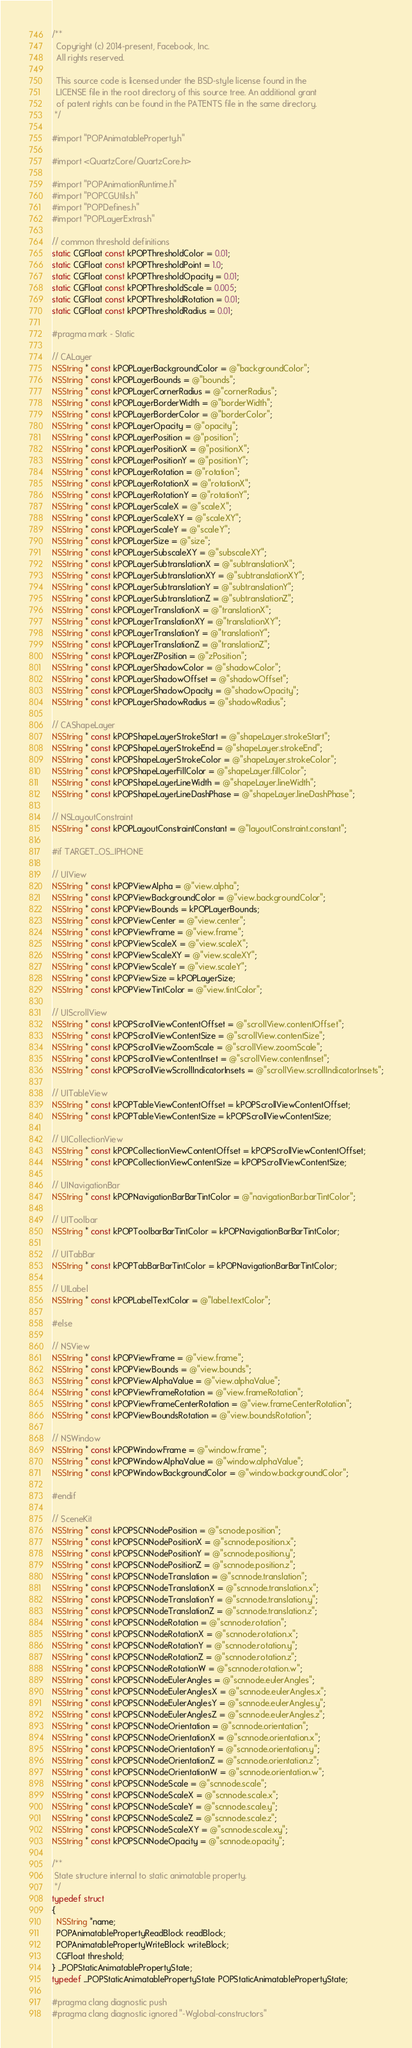<code> <loc_0><loc_0><loc_500><loc_500><_ObjectiveC_>/**
  Copyright (c) 2014-present, Facebook, Inc.
  All rights reserved.

  This source code is licensed under the BSD-style license found in the
  LICENSE file in the root directory of this source tree. An additional grant
  of patent rights can be found in the PATENTS file in the same directory.
 */

#import "POPAnimatableProperty.h"

#import <QuartzCore/QuartzCore.h>

#import "POPAnimationRuntime.h"
#import "POPCGUtils.h"
#import "POPDefines.h"
#import "POPLayerExtras.h"

// common threshold definitions
static CGFloat const kPOPThresholdColor = 0.01;
static CGFloat const kPOPThresholdPoint = 1.0;
static CGFloat const kPOPThresholdOpacity = 0.01;
static CGFloat const kPOPThresholdScale = 0.005;
static CGFloat const kPOPThresholdRotation = 0.01;
static CGFloat const kPOPThresholdRadius = 0.01;

#pragma mark - Static

// CALayer
NSString * const kPOPLayerBackgroundColor = @"backgroundColor";
NSString * const kPOPLayerBounds = @"bounds";
NSString * const kPOPLayerCornerRadius = @"cornerRadius";
NSString * const kPOPLayerBorderWidth = @"borderWidth";
NSString * const kPOPLayerBorderColor = @"borderColor";
NSString * const kPOPLayerOpacity = @"opacity";
NSString * const kPOPLayerPosition = @"position";
NSString * const kPOPLayerPositionX = @"positionX";
NSString * const kPOPLayerPositionY = @"positionY";
NSString * const kPOPLayerRotation = @"rotation";
NSString * const kPOPLayerRotationX = @"rotationX";
NSString * const kPOPLayerRotationY = @"rotationY";
NSString * const kPOPLayerScaleX = @"scaleX";
NSString * const kPOPLayerScaleXY = @"scaleXY";
NSString * const kPOPLayerScaleY = @"scaleY";
NSString * const kPOPLayerSize = @"size";
NSString * const kPOPLayerSubscaleXY = @"subscaleXY";
NSString * const kPOPLayerSubtranslationX = @"subtranslationX";
NSString * const kPOPLayerSubtranslationXY = @"subtranslationXY";
NSString * const kPOPLayerSubtranslationY = @"subtranslationY";
NSString * const kPOPLayerSubtranslationZ = @"subtranslationZ";
NSString * const kPOPLayerTranslationX = @"translationX";
NSString * const kPOPLayerTranslationXY = @"translationXY";
NSString * const kPOPLayerTranslationY = @"translationY";
NSString * const kPOPLayerTranslationZ = @"translationZ";
NSString * const kPOPLayerZPosition = @"zPosition";
NSString * const kPOPLayerShadowColor = @"shadowColor";
NSString * const kPOPLayerShadowOffset = @"shadowOffset";
NSString * const kPOPLayerShadowOpacity = @"shadowOpacity";
NSString * const kPOPLayerShadowRadius = @"shadowRadius";

// CAShapeLayer
NSString * const kPOPShapeLayerStrokeStart = @"shapeLayer.strokeStart";
NSString * const kPOPShapeLayerStrokeEnd = @"shapeLayer.strokeEnd";
NSString * const kPOPShapeLayerStrokeColor = @"shapeLayer.strokeColor";
NSString * const kPOPShapeLayerFillColor = @"shapeLayer.fillColor";
NSString * const kPOPShapeLayerLineWidth = @"shapeLayer.lineWidth";
NSString * const kPOPShapeLayerLineDashPhase = @"shapeLayer.lineDashPhase";

// NSLayoutConstraint
NSString * const kPOPLayoutConstraintConstant = @"layoutConstraint.constant";

#if TARGET_OS_IPHONE

// UIView
NSString * const kPOPViewAlpha = @"view.alpha";
NSString * const kPOPViewBackgroundColor = @"view.backgroundColor";
NSString * const kPOPViewBounds = kPOPLayerBounds;
NSString * const kPOPViewCenter = @"view.center";
NSString * const kPOPViewFrame = @"view.frame";
NSString * const kPOPViewScaleX = @"view.scaleX";
NSString * const kPOPViewScaleXY = @"view.scaleXY";
NSString * const kPOPViewScaleY = @"view.scaleY";
NSString * const kPOPViewSize = kPOPLayerSize;
NSString * const kPOPViewTintColor = @"view.tintColor";

// UIScrollView
NSString * const kPOPScrollViewContentOffset = @"scrollView.contentOffset";
NSString * const kPOPScrollViewContentSize = @"scrollView.contentSize";
NSString * const kPOPScrollViewZoomScale = @"scrollView.zoomScale";
NSString * const kPOPScrollViewContentInset = @"scrollView.contentInset";
NSString * const kPOPScrollViewScrollIndicatorInsets = @"scrollView.scrollIndicatorInsets";

// UITableView
NSString * const kPOPTableViewContentOffset = kPOPScrollViewContentOffset;
NSString * const kPOPTableViewContentSize = kPOPScrollViewContentSize;

// UICollectionView
NSString * const kPOPCollectionViewContentOffset = kPOPScrollViewContentOffset;
NSString * const kPOPCollectionViewContentSize = kPOPScrollViewContentSize;

// UINavigationBar
NSString * const kPOPNavigationBarBarTintColor = @"navigationBar.barTintColor";

// UIToolbar
NSString * const kPOPToolbarBarTintColor = kPOPNavigationBarBarTintColor;

// UITabBar
NSString * const kPOPTabBarBarTintColor = kPOPNavigationBarBarTintColor;

// UILabel
NSString * const kPOPLabelTextColor = @"label.textColor";

#else

// NSView
NSString * const kPOPViewFrame = @"view.frame";
NSString * const kPOPViewBounds = @"view.bounds";
NSString * const kPOPViewAlphaValue = @"view.alphaValue";
NSString * const kPOPViewFrameRotation = @"view.frameRotation";
NSString * const kPOPViewFrameCenterRotation = @"view.frameCenterRotation";
NSString * const kPOPViewBoundsRotation = @"view.boundsRotation";

// NSWindow
NSString * const kPOPWindowFrame = @"window.frame";
NSString * const kPOPWindowAlphaValue = @"window.alphaValue";
NSString * const kPOPWindowBackgroundColor = @"window.backgroundColor";

#endif

// SceneKit
NSString * const kPOPSCNNodePosition = @"scnode.position";
NSString * const kPOPSCNNodePositionX = @"scnnode.position.x";
NSString * const kPOPSCNNodePositionY = @"scnnode.position.y";
NSString * const kPOPSCNNodePositionZ = @"scnnode.position.z";
NSString * const kPOPSCNNodeTranslation = @"scnnode.translation";
NSString * const kPOPSCNNodeTranslationX = @"scnnode.translation.x";
NSString * const kPOPSCNNodeTranslationY = @"scnnode.translation.y";
NSString * const kPOPSCNNodeTranslationZ = @"scnnode.translation.z";
NSString * const kPOPSCNNodeRotation = @"scnnode.rotation";
NSString * const kPOPSCNNodeRotationX = @"scnnode.rotation.x";
NSString * const kPOPSCNNodeRotationY = @"scnnode.rotation.y";
NSString * const kPOPSCNNodeRotationZ = @"scnnode.rotation.z";
NSString * const kPOPSCNNodeRotationW = @"scnnode.rotation.w";
NSString * const kPOPSCNNodeEulerAngles = @"scnnode.eulerAngles";
NSString * const kPOPSCNNodeEulerAnglesX = @"scnnode.eulerAngles.x";
NSString * const kPOPSCNNodeEulerAnglesY = @"scnnode.eulerAngles.y";
NSString * const kPOPSCNNodeEulerAnglesZ = @"scnnode.eulerAngles.z";
NSString * const kPOPSCNNodeOrientation = @"scnnode.orientation";
NSString * const kPOPSCNNodeOrientationX = @"scnnode.orientation.x";
NSString * const kPOPSCNNodeOrientationY = @"scnnode.orientation.y";
NSString * const kPOPSCNNodeOrientationZ = @"scnnode.orientation.z";
NSString * const kPOPSCNNodeOrientationW = @"scnnode.orientation.w";
NSString * const kPOPSCNNodeScale = @"scnnode.scale";
NSString * const kPOPSCNNodeScaleX = @"scnnode.scale.x";
NSString * const kPOPSCNNodeScaleY = @"scnnode.scale.y";
NSString * const kPOPSCNNodeScaleZ = @"scnnode.scale.z";
NSString * const kPOPSCNNodeScaleXY = @"scnnode.scale.xy";
NSString * const kPOPSCNNodeOpacity = @"scnnode.opacity";

/**
 State structure internal to static animatable property.
 */
typedef struct
{
  NSString *name;
  POPAnimatablePropertyReadBlock readBlock;
  POPAnimatablePropertyWriteBlock writeBlock;
  CGFloat threshold;
} _POPStaticAnimatablePropertyState;
typedef _POPStaticAnimatablePropertyState POPStaticAnimatablePropertyState;

#pragma clang diagnostic push
#pragma clang diagnostic ignored "-Wglobal-constructors"</code> 